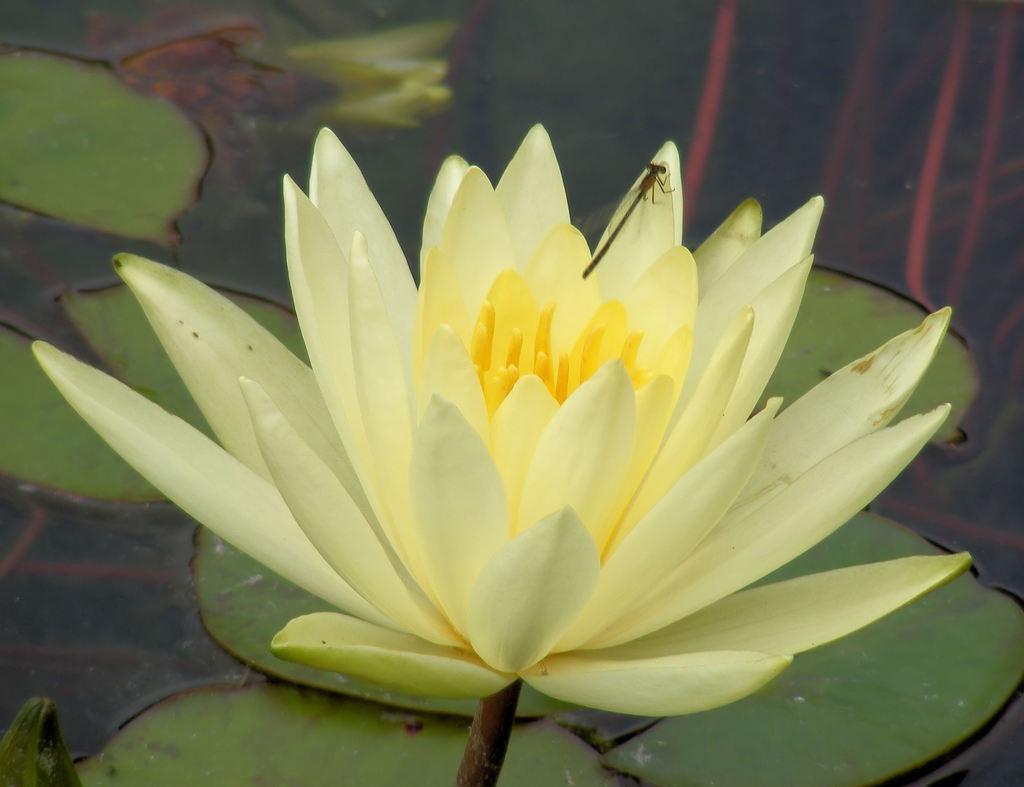Describe this image in one or two sentences. In the image there is a dragonfly standing on lotus in a pond. 